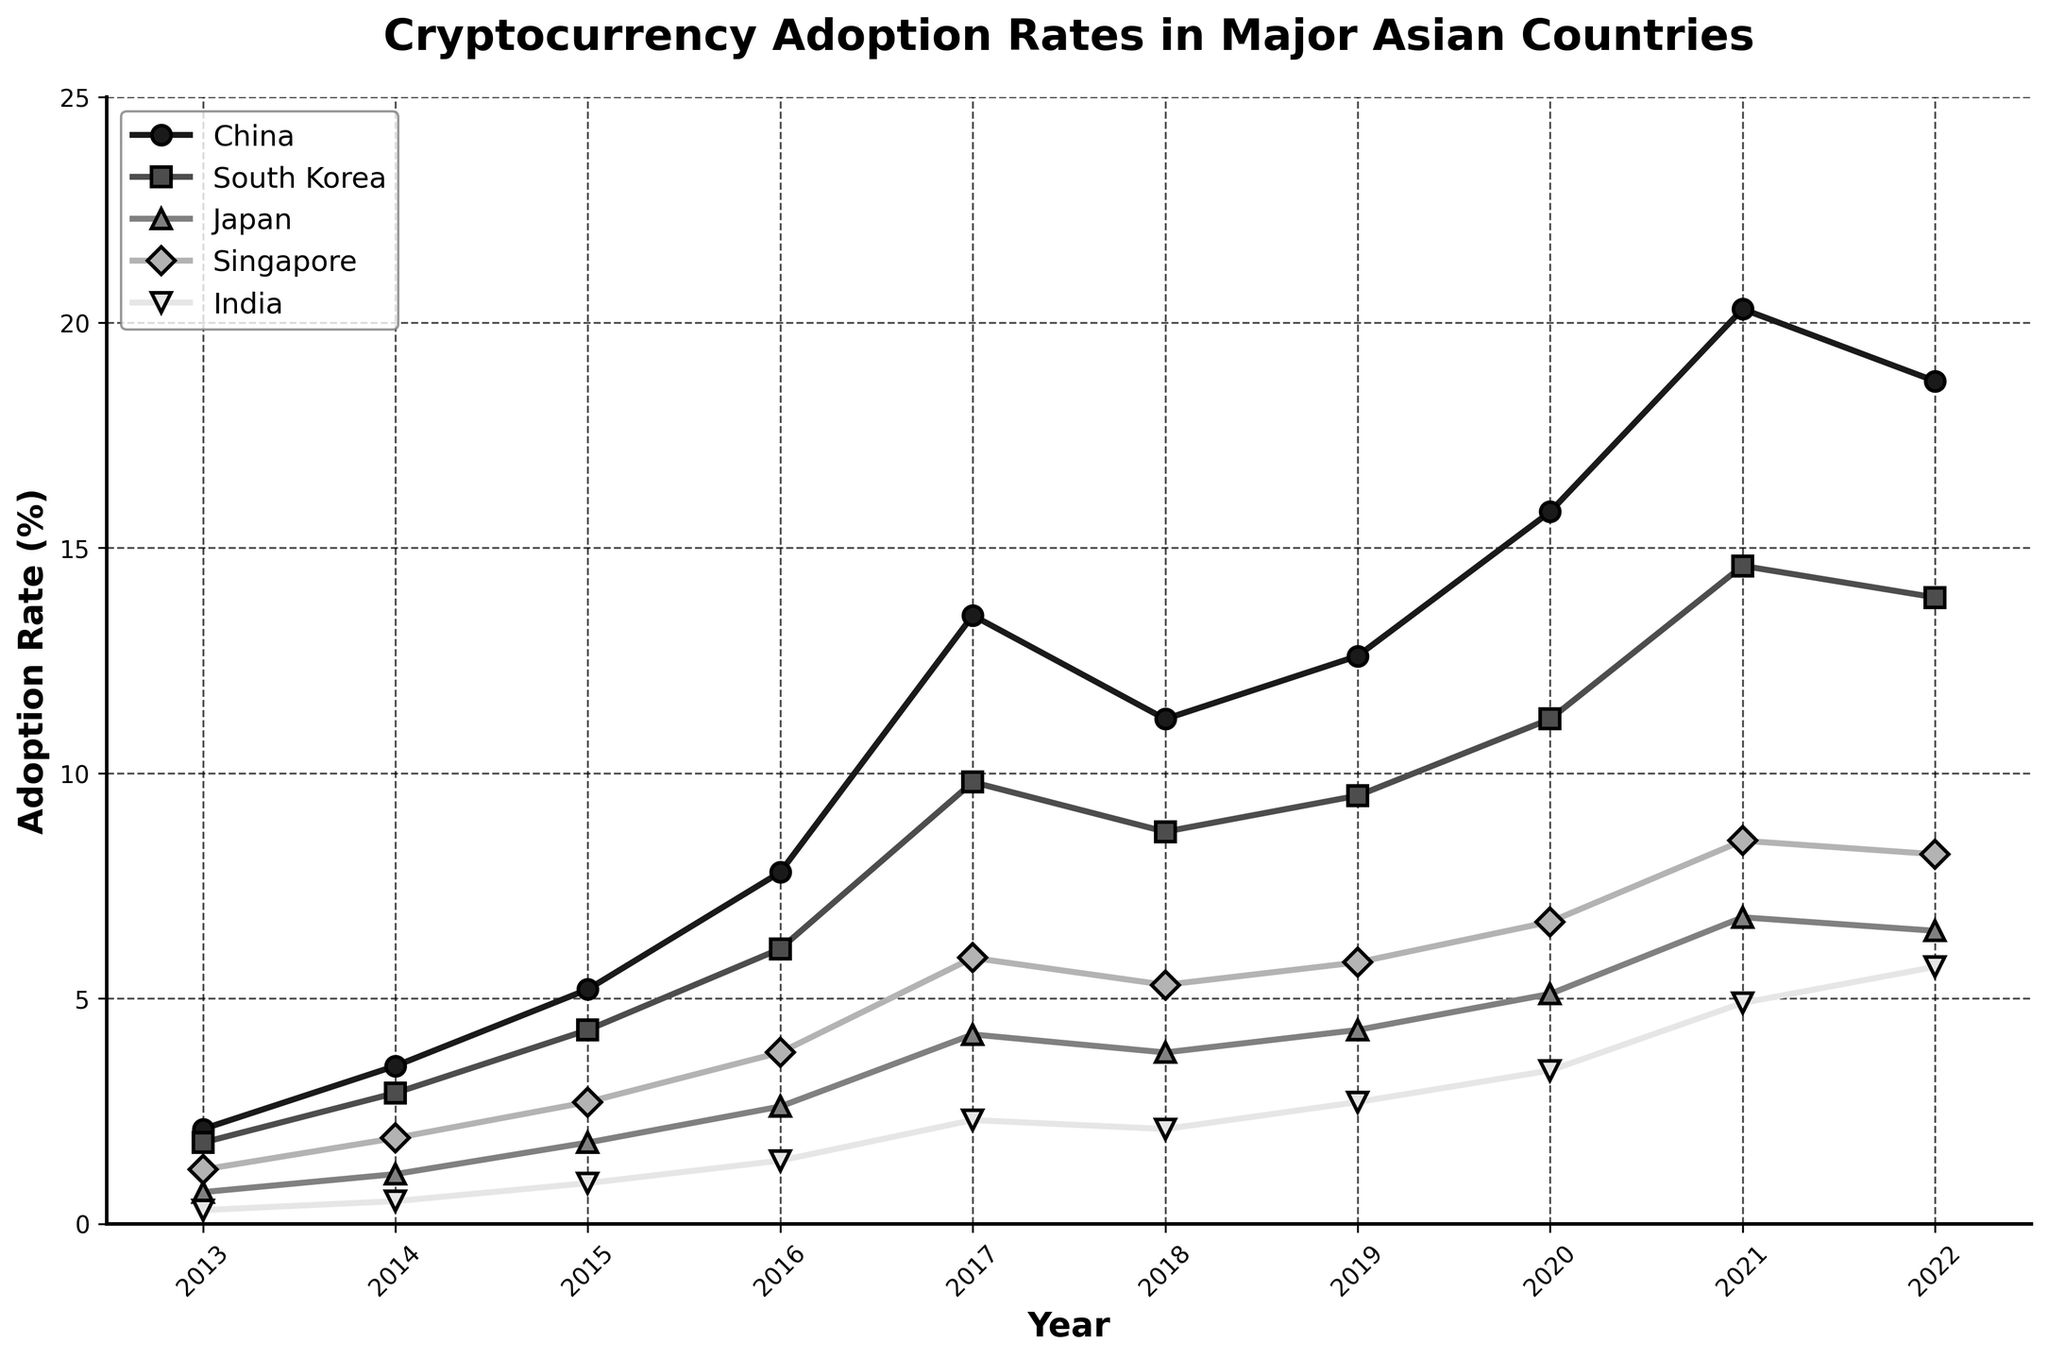What was the adoption rate for cryptocurrency in India in 2017? Look at the year 2017 on the x-axis and trace it vertically until reaching the line representing India. Read off the corresponding y-axis value, which is 2.3%.
Answer: 2.3% Which country had the highest adoption rate in 2021? Check the value for each country in the year 2021 and compare them. China's adoption rate of 20.3% is the highest.
Answer: China Between which consecutive years did China's cryptocurrency adoption rate increase the most? Calculate the differences in adoption rates between consecutive years for China and identify the largest increase: from 2016 to 2017, the increase is 13.5-7.8 = 5.7. This is the largest increase.
Answer: 2016 to 2017 What was the average adoption rate of South Korea from 2013 to 2016? Sum the adoption rates for South Korea from 2013 to 2016 (1.8 + 2.9 + 4.3 + 6.1 = 15.1) and divide by 4 (number of years): 15.1 / 4 = 3.775%.
Answer: 3.775% Which country's adoption rate showed a decline after 2021? Observe the trends in the adoption rates after 2021 for all lines. Both China and South Korea show declines from 2021 to 2022 (China: from 20.3 to 18.7, South Korea: from 14.6 to 13.9).
Answer: China and South Korea By how much did Singapore's adoption rate increase from 2016 to 2020? Subtract the 2016 adoption rate from the 2020 rate for Singapore: 6.7 - 3.8 = 2.9.
Answer: 2.9 Which country had the smallest increase in adoption rate from 2013 to 2022? Find the difference between adoption rates in 2022 and 2013 for each country: 
China: 18.7 - 2.1 = 16.6,
South Korea: 13.9 - 1.8 = 12.1,
Japan: 6.5 - 0.7 = 5.8,
Singapore: 8.2 - 1.2 = 7.0,
India: 5.7 - 0.3 = 5.4.
India has the smallest increase of 5.4%.
Answer: India In which year did Japan's adoption rate first exceed 5%? Check the years sequentially for Japan's adoption rates exceeding 5% for the first time. In 2020, it reaches 5.1%.
Answer: 2020 How much more did China's adoption rate increase from 2020 to 2022 compared to South Korea's? Calculate the increase for both countries: China from 2020 to 2022: 18.7 - 15.8 = 2.9. South Korea from 2020 to 2022: 13.9 - 11.2 = 2.7. The difference: 2.9 - 2.7 = 0.2.
Answer: 0.2 